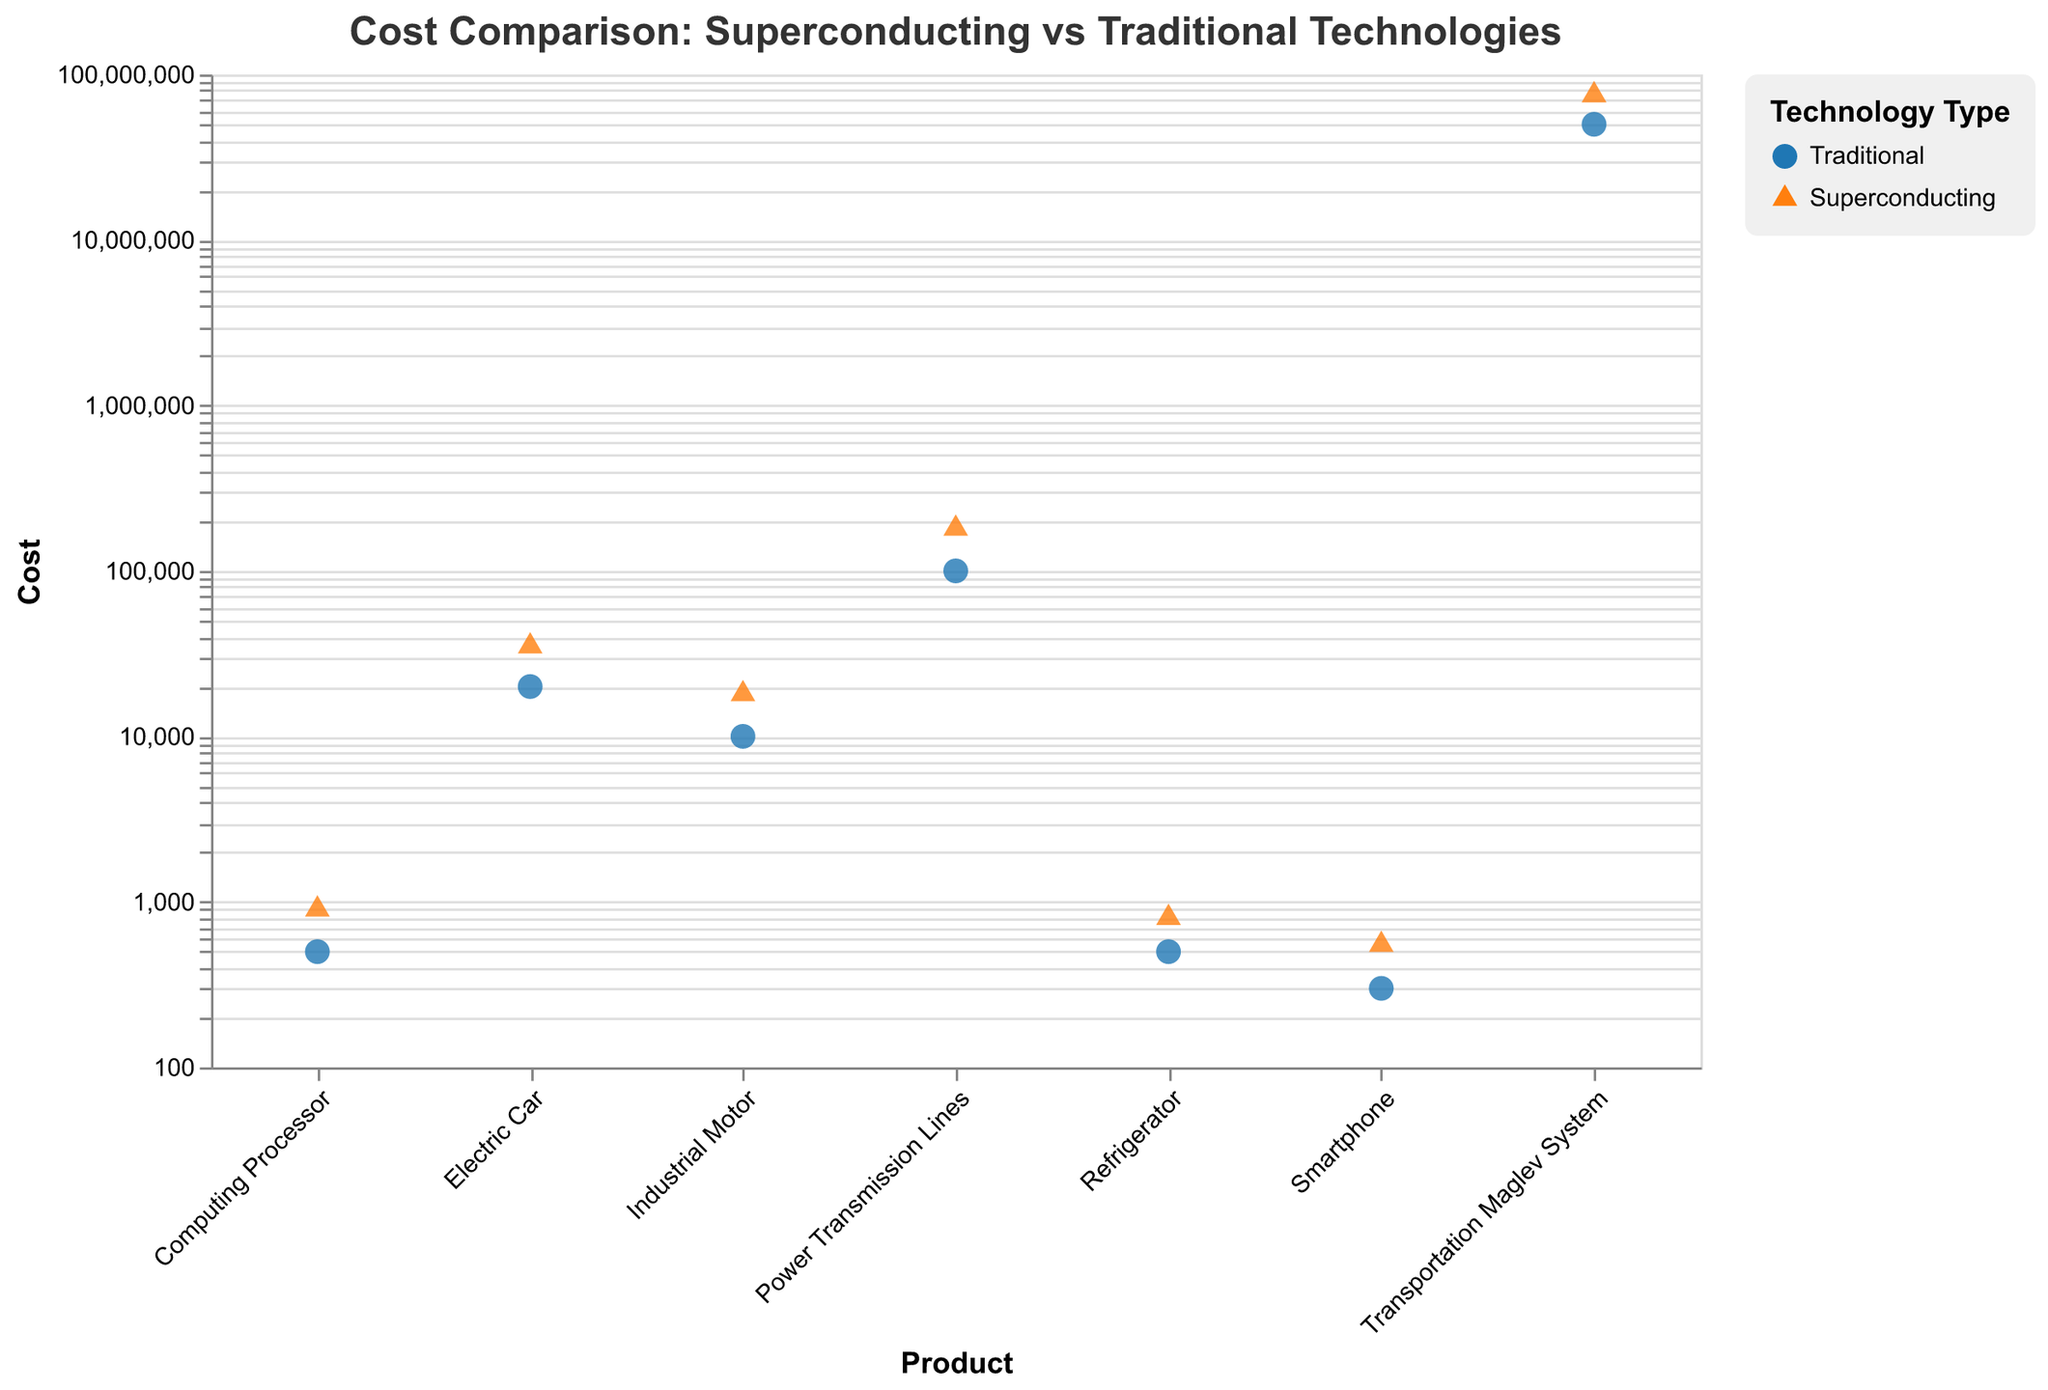what's the title of the figure? The title is usually displayed at the top of the figure in a larger or bold font. Here, the title reads "Cost Comparison: Superconducting vs Traditional Technologies".
Answer: Cost Comparison: Superconducting vs Traditional Technologies how many different products are compared in the figure? To find the number of different products, count the unique labels on the x-axis. Here, we have Refrigerator, Smartphone, Electric Car, Power Transmission Lines, Computing Processor, Transportation Maglev System, and Industrial Motor, which makes 7 different products.
Answer: 7 which product has the highest implementation cost for superconducting technology? The product with the highest implementation cost for superconducting technology can be identified by looking at the y-axis values and noting which point is highest among the orange triangle markers. The Transportation Maglev System has the highest cost at $75,000,000.
Answer: Transportation Maglev System what is the cost difference between traditional and superconducting technology for the Electric Car? Find the y-axis values for both traditional and superconducting technologies for the Electric Car, then subtract the traditional cost from the superconducting cost. The traditional cost is $20,000 and the superconducting cost is $35,000. The difference is $35,000 - $20,000 = $15,000.
Answer: $15,000 which product shows the smallest cost increase when switching from traditional to superconducting technology? Identify and compare the cost differences (y-axis values) between traditional and superconducting technologies for all products. The smallest increase is for the Refrigerator, with costs going from $500 (traditional) to $800 (superconducting), an increase of $300.
Answer: Refrigerator how many data points are there in total in the figure? Count each individual point representing both traditional and superconducting technologies for all products. There are 14 points in total, as each of the 7 products has 2 points (one for each technology).
Answer: 14 which technology is represented by the orange triangles? The legend typically identifies which shapes or colors correspond to which categories. In this figure, orange triangles represent the superconducting technology.
Answer: Superconducting how does the cost of superconducting technology for Computing Processors compare to that for Refrigerators? Compare the y-axis value of the superconducting technology for both products. For Computing Processors, the cost is $900, while for Refrigerators it is $800. The cost for Computing Processors is higher.
Answer: Higher which product shows the largest relative cost increase when switching from traditional to superconducting technology? Calculate the relative cost increase for each product by subtracting the traditional cost from the superconducting cost, dividing by the traditional cost, and comparing these ratios. The Transportation Maglev System has the largest increase, going from $50,000,000 (traditional) to $75,000,000 (superconducting), a 50% increase.
Answer: Transportation Maglev System is the implementation cost for superconducting technology always higher than traditional technology across all products? Compare each pair of points for all products, checking if the cost for superconducting technology (orange triangles) is always higher than the traditional one (blue circles). Yes, in each case, the superconducting technology is more expensive.
Answer: Yes 